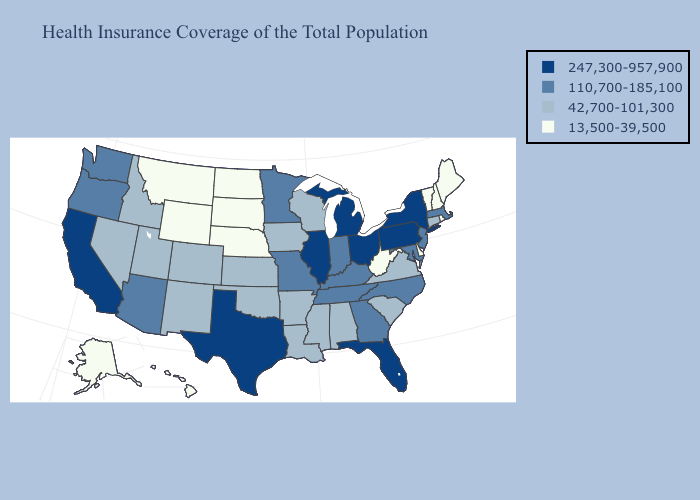What is the highest value in the USA?
Quick response, please. 247,300-957,900. Which states have the highest value in the USA?
Write a very short answer. California, Florida, Illinois, Michigan, New York, Ohio, Pennsylvania, Texas. Among the states that border Utah , does Wyoming have the highest value?
Answer briefly. No. Among the states that border Illinois , does Wisconsin have the lowest value?
Answer briefly. Yes. What is the lowest value in states that border South Dakota?
Write a very short answer. 13,500-39,500. What is the highest value in the Northeast ?
Quick response, please. 247,300-957,900. Name the states that have a value in the range 110,700-185,100?
Concise answer only. Arizona, Georgia, Indiana, Kentucky, Maryland, Massachusetts, Minnesota, Missouri, New Jersey, North Carolina, Oregon, Tennessee, Washington. How many symbols are there in the legend?
Keep it brief. 4. Is the legend a continuous bar?
Write a very short answer. No. What is the value of Montana?
Answer briefly. 13,500-39,500. Name the states that have a value in the range 42,700-101,300?
Be succinct. Alabama, Arkansas, Colorado, Connecticut, Idaho, Iowa, Kansas, Louisiana, Mississippi, Nevada, New Mexico, Oklahoma, South Carolina, Utah, Virginia, Wisconsin. Name the states that have a value in the range 42,700-101,300?
Give a very brief answer. Alabama, Arkansas, Colorado, Connecticut, Idaho, Iowa, Kansas, Louisiana, Mississippi, Nevada, New Mexico, Oklahoma, South Carolina, Utah, Virginia, Wisconsin. Does Minnesota have a lower value than Wyoming?
Answer briefly. No. What is the value of Tennessee?
Short answer required. 110,700-185,100. Which states have the lowest value in the MidWest?
Give a very brief answer. Nebraska, North Dakota, South Dakota. 